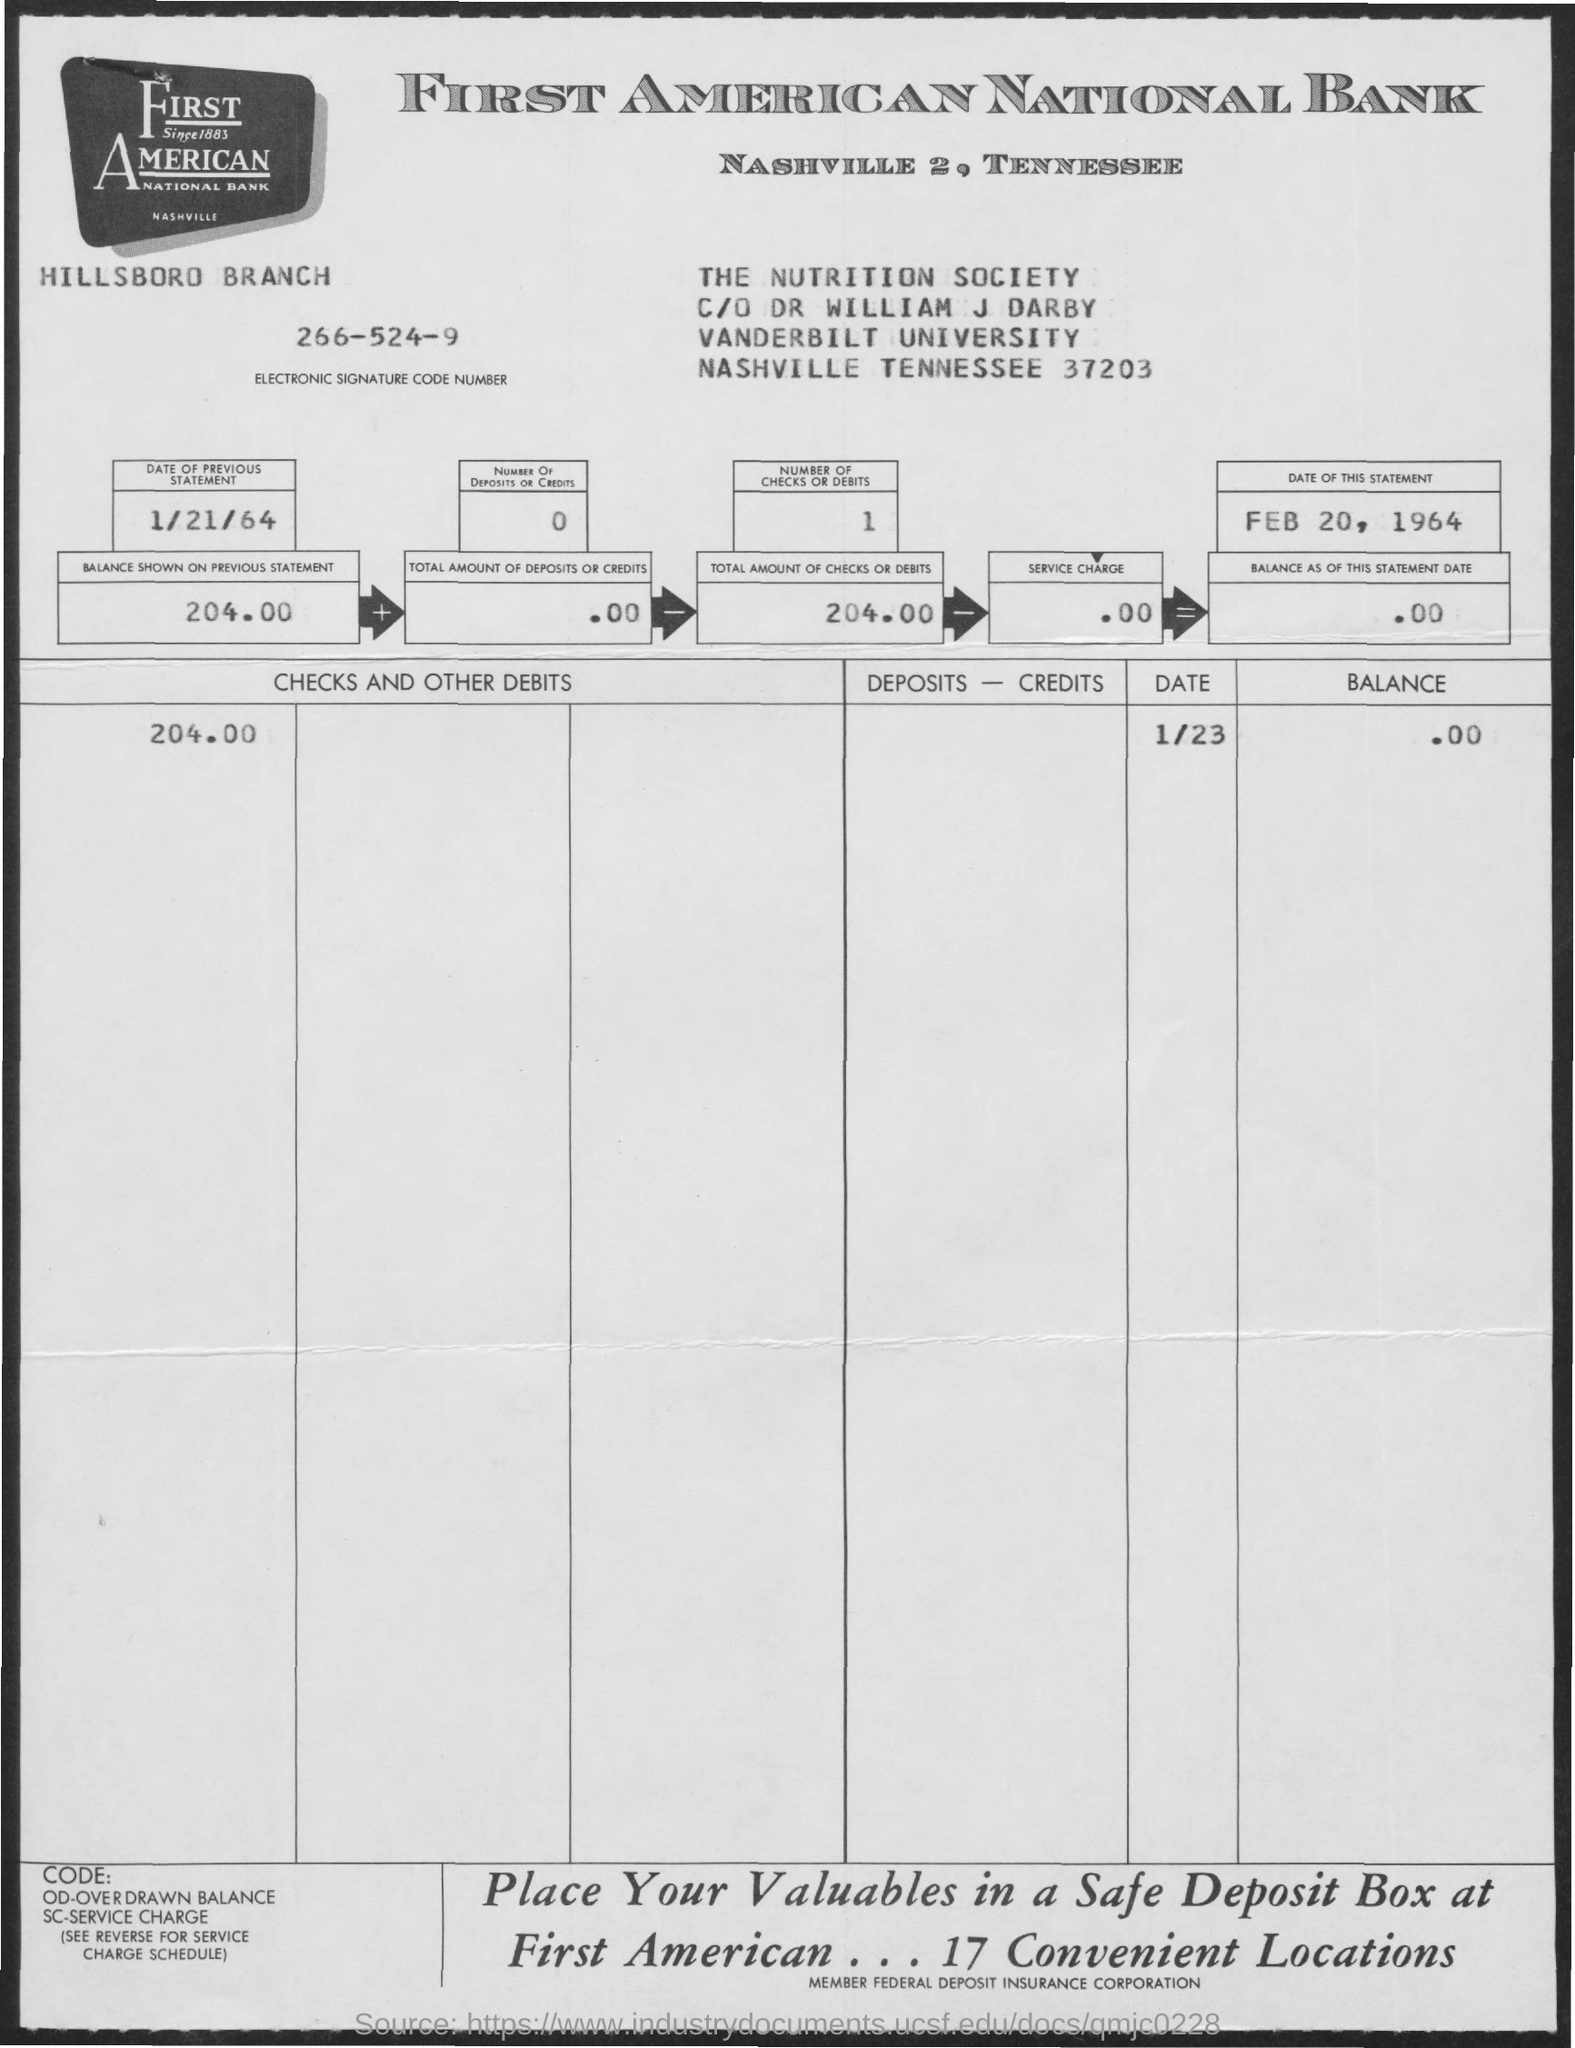Is there any additional information about the account holder or associated individuals on the statement? Yes, the bank statement is addressed to The Nutrition Society care of Dr. William J. Darby, who appears to be associated with Vanderbilt University in Nashville, Tennessee. This suggests that the account could be used for depositing funds related to nutritional research or academic activities coordinated by Dr. Darby at the university. 